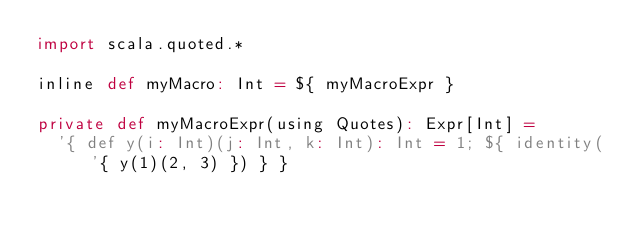<code> <loc_0><loc_0><loc_500><loc_500><_Scala_>import scala.quoted.*

inline def myMacro: Int = ${ myMacroExpr }

private def myMacroExpr(using Quotes): Expr[Int] =
  '{ def y(i: Int)(j: Int, k: Int): Int = 1; ${ identity('{ y(1)(2, 3) }) } }
</code> 